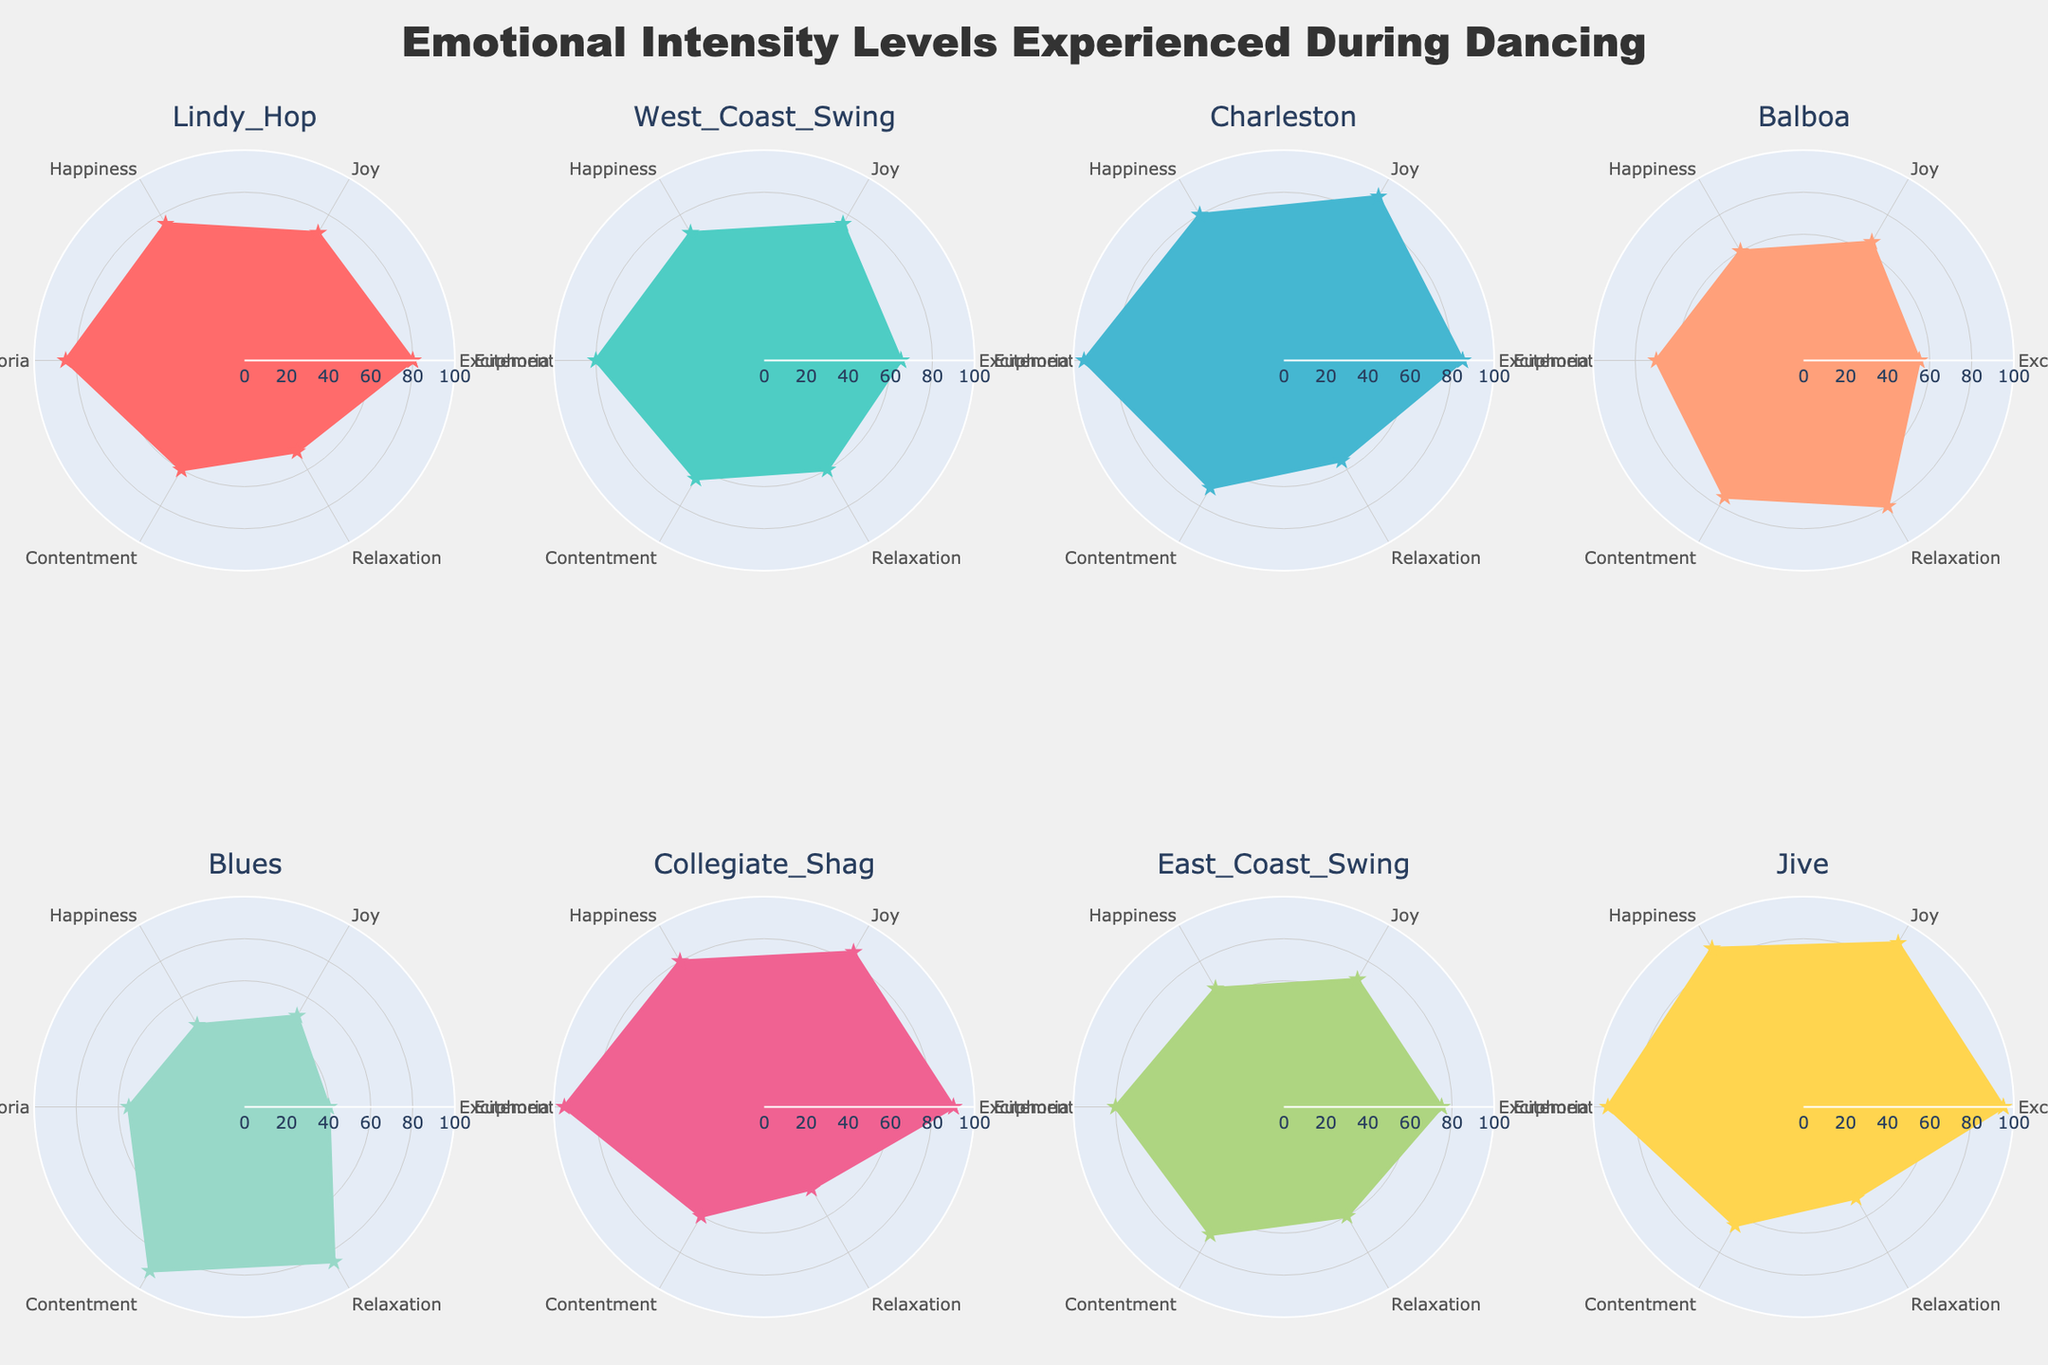What is the title of the figure? The title is positioned at the top center of the figure and is written in large, bold font. It states the overall theme or subject being represented in the figure.
Answer: Emotional Intensity Levels Experienced During Dancing Which dance style has the highest excitement level? In the subplot for each dance style, the excitement level is indicated along the radial axis. The subplot for Jive shows the highest value for excitement.
Answer: Jive Compare the relaxation levels between Balboa and Collegiate Shag. Which one has a higher value? To compare, locate the relaxation value in the respective subplots for Balboa and Collegiate Shag. Balboa shows a relaxation level of 80, whereas Collegiate Shag has 45.
Answer: Balboa What is the average happiness level for Lindy Hop and East Coast Swing? For Lindy Hop, the happiness level is 75, and for East Coast Swing, it's 65. The average of these two values is (75 + 65) / 2.
Answer: 70 Which dance style shows the lowest level of contentment? In the subplots, locate the contentment values for each dance style. Blues shows the highest contentment, while Lindy Hop, Collegiate Shag, and Jive show lower values. Among these, Jive shows the lowest value.
Answer: Jive Look at contentment levels across all dance styles. Which two dance styles have the same value? By examining the contentment values in each subplot, we see that both East Coast Swing and Charleston have a contentment level of 70.
Answer: East Coast Swing and Charleston Summing up the joy levels of West Coast Swing and Charleston, what is the result? The joy level for West Coast Swing is 75, and for Charleston, it's 90. Summing these values gives 75 + 90.
Answer: 165 Out of all the dance styles, which one shows the highest euphoria level? Euphoria levels are shown in each subplot. Charleston and Collegiate Shag both show a level of 95, which is the highest.
Answer: Charleston and Collegiate Shag Describe the color and shape used to represent the Jive polar chart. The Jive polar chart is represented in a bright color (yellow-orange), with the data points connected by lines and a star shape marker at each point.
Answer: Yellow-orange and star shape markers Considering excitement and euphoria levels, which dance style shows an equal or almost equal intensity for both emotions? Examine both excitement and euphoria levels for each dance style. Jive shows 95 for excitement and 93 for euphoria, which are very close in values.
Answer: Jive 